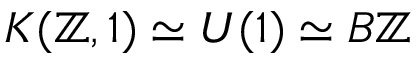Convert formula to latex. <formula><loc_0><loc_0><loc_500><loc_500>K ( \mathbb { Z } , 1 ) \simeq U ( 1 ) \simeq B \mathbb { Z }</formula> 